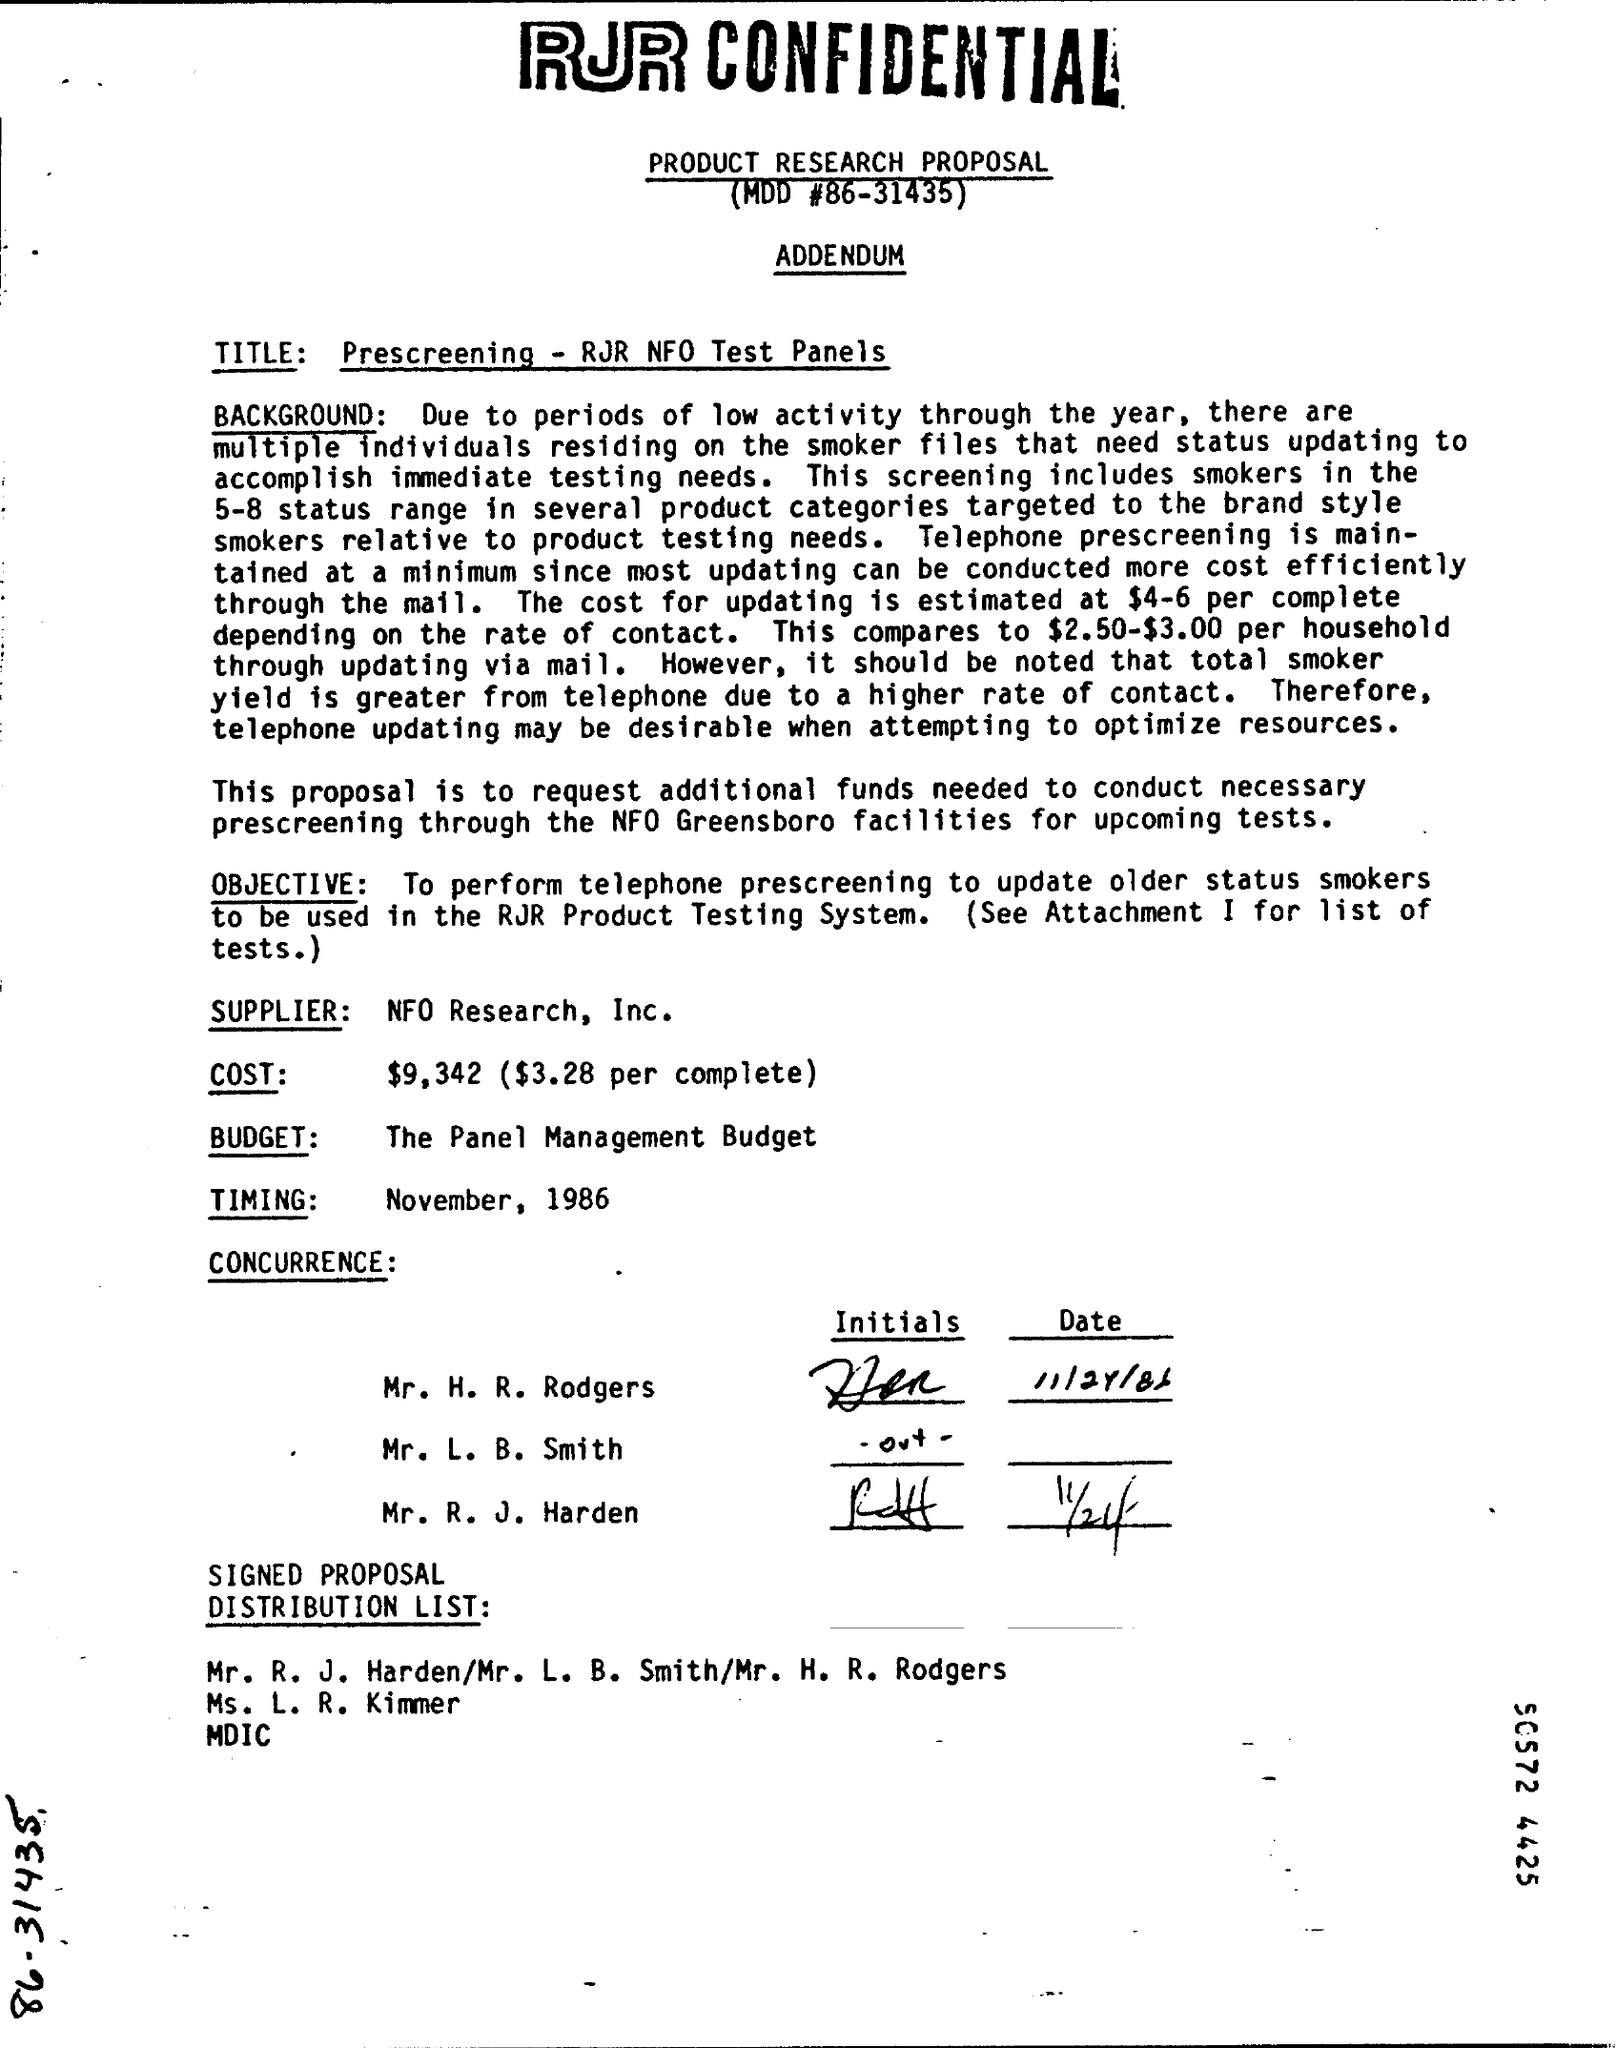What is MOD #?
Your answer should be compact. 86-31435. What is the TITLE?
Provide a succinct answer. Prescreening - RJR NFO Test Panels. Who is the Supplier?
Give a very brief answer. NFO Research, Inc. What is the Budget?
Your response must be concise. The Panel Management Budget. What is the Timing?
Ensure brevity in your answer.  November, 1986. 